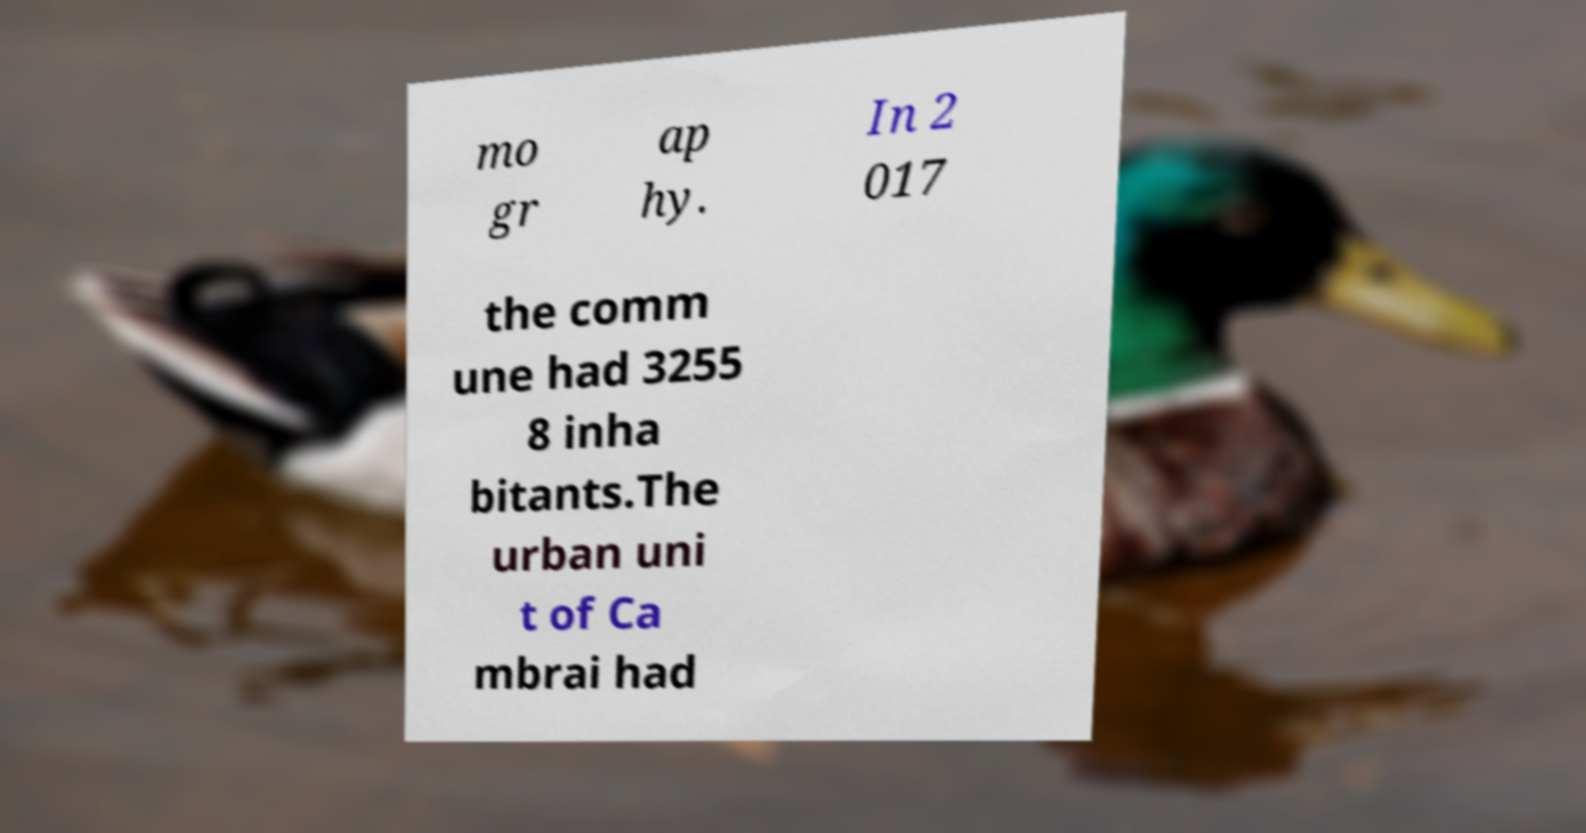There's text embedded in this image that I need extracted. Can you transcribe it verbatim? mo gr ap hy. In 2 017 the comm une had 3255 8 inha bitants.The urban uni t of Ca mbrai had 